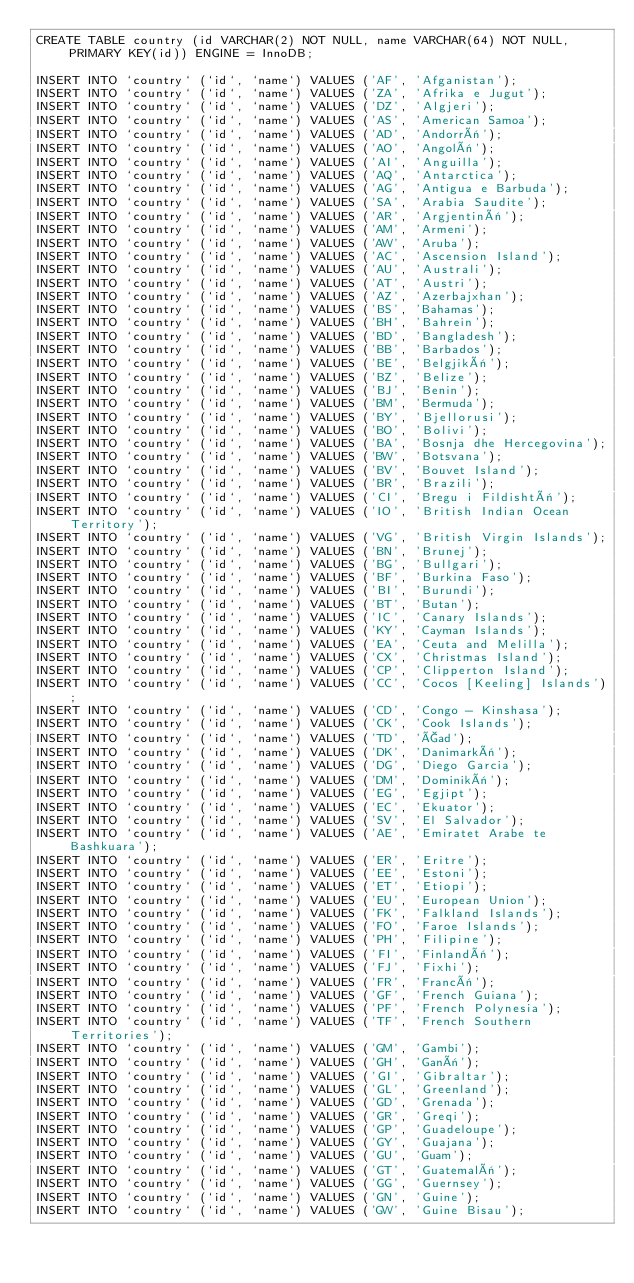Convert code to text. <code><loc_0><loc_0><loc_500><loc_500><_SQL_>CREATE TABLE country (id VARCHAR(2) NOT NULL, name VARCHAR(64) NOT NULL, PRIMARY KEY(id)) ENGINE = InnoDB;

INSERT INTO `country` (`id`, `name`) VALUES ('AF', 'Afganistan');
INSERT INTO `country` (`id`, `name`) VALUES ('ZA', 'Afrika e Jugut');
INSERT INTO `country` (`id`, `name`) VALUES ('DZ', 'Algjeri');
INSERT INTO `country` (`id`, `name`) VALUES ('AS', 'American Samoa');
INSERT INTO `country` (`id`, `name`) VALUES ('AD', 'Andorrë');
INSERT INTO `country` (`id`, `name`) VALUES ('AO', 'Angolë');
INSERT INTO `country` (`id`, `name`) VALUES ('AI', 'Anguilla');
INSERT INTO `country` (`id`, `name`) VALUES ('AQ', 'Antarctica');
INSERT INTO `country` (`id`, `name`) VALUES ('AG', 'Antigua e Barbuda');
INSERT INTO `country` (`id`, `name`) VALUES ('SA', 'Arabia Saudite');
INSERT INTO `country` (`id`, `name`) VALUES ('AR', 'Argjentinë');
INSERT INTO `country` (`id`, `name`) VALUES ('AM', 'Armeni');
INSERT INTO `country` (`id`, `name`) VALUES ('AW', 'Aruba');
INSERT INTO `country` (`id`, `name`) VALUES ('AC', 'Ascension Island');
INSERT INTO `country` (`id`, `name`) VALUES ('AU', 'Australi');
INSERT INTO `country` (`id`, `name`) VALUES ('AT', 'Austri');
INSERT INTO `country` (`id`, `name`) VALUES ('AZ', 'Azerbajxhan');
INSERT INTO `country` (`id`, `name`) VALUES ('BS', 'Bahamas');
INSERT INTO `country` (`id`, `name`) VALUES ('BH', 'Bahrein');
INSERT INTO `country` (`id`, `name`) VALUES ('BD', 'Bangladesh');
INSERT INTO `country` (`id`, `name`) VALUES ('BB', 'Barbados');
INSERT INTO `country` (`id`, `name`) VALUES ('BE', 'Belgjikë');
INSERT INTO `country` (`id`, `name`) VALUES ('BZ', 'Belize');
INSERT INTO `country` (`id`, `name`) VALUES ('BJ', 'Benin');
INSERT INTO `country` (`id`, `name`) VALUES ('BM', 'Bermuda');
INSERT INTO `country` (`id`, `name`) VALUES ('BY', 'Bjellorusi');
INSERT INTO `country` (`id`, `name`) VALUES ('BO', 'Bolivi');
INSERT INTO `country` (`id`, `name`) VALUES ('BA', 'Bosnja dhe Hercegovina');
INSERT INTO `country` (`id`, `name`) VALUES ('BW', 'Botsvana');
INSERT INTO `country` (`id`, `name`) VALUES ('BV', 'Bouvet Island');
INSERT INTO `country` (`id`, `name`) VALUES ('BR', 'Brazili');
INSERT INTO `country` (`id`, `name`) VALUES ('CI', 'Bregu i Fildishtë');
INSERT INTO `country` (`id`, `name`) VALUES ('IO', 'British Indian Ocean Territory');
INSERT INTO `country` (`id`, `name`) VALUES ('VG', 'British Virgin Islands');
INSERT INTO `country` (`id`, `name`) VALUES ('BN', 'Brunej');
INSERT INTO `country` (`id`, `name`) VALUES ('BG', 'Bullgari');
INSERT INTO `country` (`id`, `name`) VALUES ('BF', 'Burkina Faso');
INSERT INTO `country` (`id`, `name`) VALUES ('BI', 'Burundi');
INSERT INTO `country` (`id`, `name`) VALUES ('BT', 'Butan');
INSERT INTO `country` (`id`, `name`) VALUES ('IC', 'Canary Islands');
INSERT INTO `country` (`id`, `name`) VALUES ('KY', 'Cayman Islands');
INSERT INTO `country` (`id`, `name`) VALUES ('EA', 'Ceuta and Melilla');
INSERT INTO `country` (`id`, `name`) VALUES ('CX', 'Christmas Island');
INSERT INTO `country` (`id`, `name`) VALUES ('CP', 'Clipperton Island');
INSERT INTO `country` (`id`, `name`) VALUES ('CC', 'Cocos [Keeling] Islands');
INSERT INTO `country` (`id`, `name`) VALUES ('CD', 'Congo - Kinshasa');
INSERT INTO `country` (`id`, `name`) VALUES ('CK', 'Cook Islands');
INSERT INTO `country` (`id`, `name`) VALUES ('TD', 'Çad');
INSERT INTO `country` (`id`, `name`) VALUES ('DK', 'Danimarkë');
INSERT INTO `country` (`id`, `name`) VALUES ('DG', 'Diego Garcia');
INSERT INTO `country` (`id`, `name`) VALUES ('DM', 'Dominikë');
INSERT INTO `country` (`id`, `name`) VALUES ('EG', 'Egjipt');
INSERT INTO `country` (`id`, `name`) VALUES ('EC', 'Ekuator');
INSERT INTO `country` (`id`, `name`) VALUES ('SV', 'El Salvador');
INSERT INTO `country` (`id`, `name`) VALUES ('AE', 'Emiratet Arabe te Bashkuara');
INSERT INTO `country` (`id`, `name`) VALUES ('ER', 'Eritre');
INSERT INTO `country` (`id`, `name`) VALUES ('EE', 'Estoni');
INSERT INTO `country` (`id`, `name`) VALUES ('ET', 'Etiopi');
INSERT INTO `country` (`id`, `name`) VALUES ('EU', 'European Union');
INSERT INTO `country` (`id`, `name`) VALUES ('FK', 'Falkland Islands');
INSERT INTO `country` (`id`, `name`) VALUES ('FO', 'Faroe Islands');
INSERT INTO `country` (`id`, `name`) VALUES ('PH', 'Filipine');
INSERT INTO `country` (`id`, `name`) VALUES ('FI', 'Finlandë');
INSERT INTO `country` (`id`, `name`) VALUES ('FJ', 'Fixhi');
INSERT INTO `country` (`id`, `name`) VALUES ('FR', 'Francë');
INSERT INTO `country` (`id`, `name`) VALUES ('GF', 'French Guiana');
INSERT INTO `country` (`id`, `name`) VALUES ('PF', 'French Polynesia');
INSERT INTO `country` (`id`, `name`) VALUES ('TF', 'French Southern Territories');
INSERT INTO `country` (`id`, `name`) VALUES ('GM', 'Gambi');
INSERT INTO `country` (`id`, `name`) VALUES ('GH', 'Ganë');
INSERT INTO `country` (`id`, `name`) VALUES ('GI', 'Gibraltar');
INSERT INTO `country` (`id`, `name`) VALUES ('GL', 'Greenland');
INSERT INTO `country` (`id`, `name`) VALUES ('GD', 'Grenada');
INSERT INTO `country` (`id`, `name`) VALUES ('GR', 'Greqi');
INSERT INTO `country` (`id`, `name`) VALUES ('GP', 'Guadeloupe');
INSERT INTO `country` (`id`, `name`) VALUES ('GY', 'Guajana');
INSERT INTO `country` (`id`, `name`) VALUES ('GU', 'Guam');
INSERT INTO `country` (`id`, `name`) VALUES ('GT', 'Guatemalë');
INSERT INTO `country` (`id`, `name`) VALUES ('GG', 'Guernsey');
INSERT INTO `country` (`id`, `name`) VALUES ('GN', 'Guine');
INSERT INTO `country` (`id`, `name`) VALUES ('GW', 'Guine Bisau');</code> 